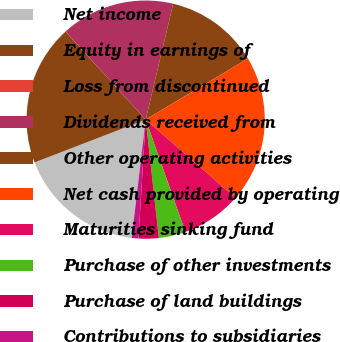<chart> <loc_0><loc_0><loc_500><loc_500><pie_chart><fcel>Net income<fcel>Equity in earnings of<fcel>Loss from discontinued<fcel>Dividends received from<fcel>Other operating activities<fcel>Net cash provided by operating<fcel>Maturities sinking fund<fcel>Purchase of other investments<fcel>Purchase of land buildings<fcel>Contributions to subsidiaries<nl><fcel>17.27%<fcel>19.09%<fcel>0.01%<fcel>15.45%<fcel>12.73%<fcel>19.99%<fcel>8.18%<fcel>3.64%<fcel>2.73%<fcel>0.91%<nl></chart> 